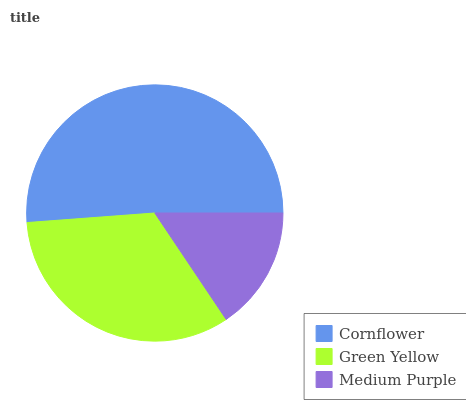Is Medium Purple the minimum?
Answer yes or no. Yes. Is Cornflower the maximum?
Answer yes or no. Yes. Is Green Yellow the minimum?
Answer yes or no. No. Is Green Yellow the maximum?
Answer yes or no. No. Is Cornflower greater than Green Yellow?
Answer yes or no. Yes. Is Green Yellow less than Cornflower?
Answer yes or no. Yes. Is Green Yellow greater than Cornflower?
Answer yes or no. No. Is Cornflower less than Green Yellow?
Answer yes or no. No. Is Green Yellow the high median?
Answer yes or no. Yes. Is Green Yellow the low median?
Answer yes or no. Yes. Is Cornflower the high median?
Answer yes or no. No. Is Cornflower the low median?
Answer yes or no. No. 